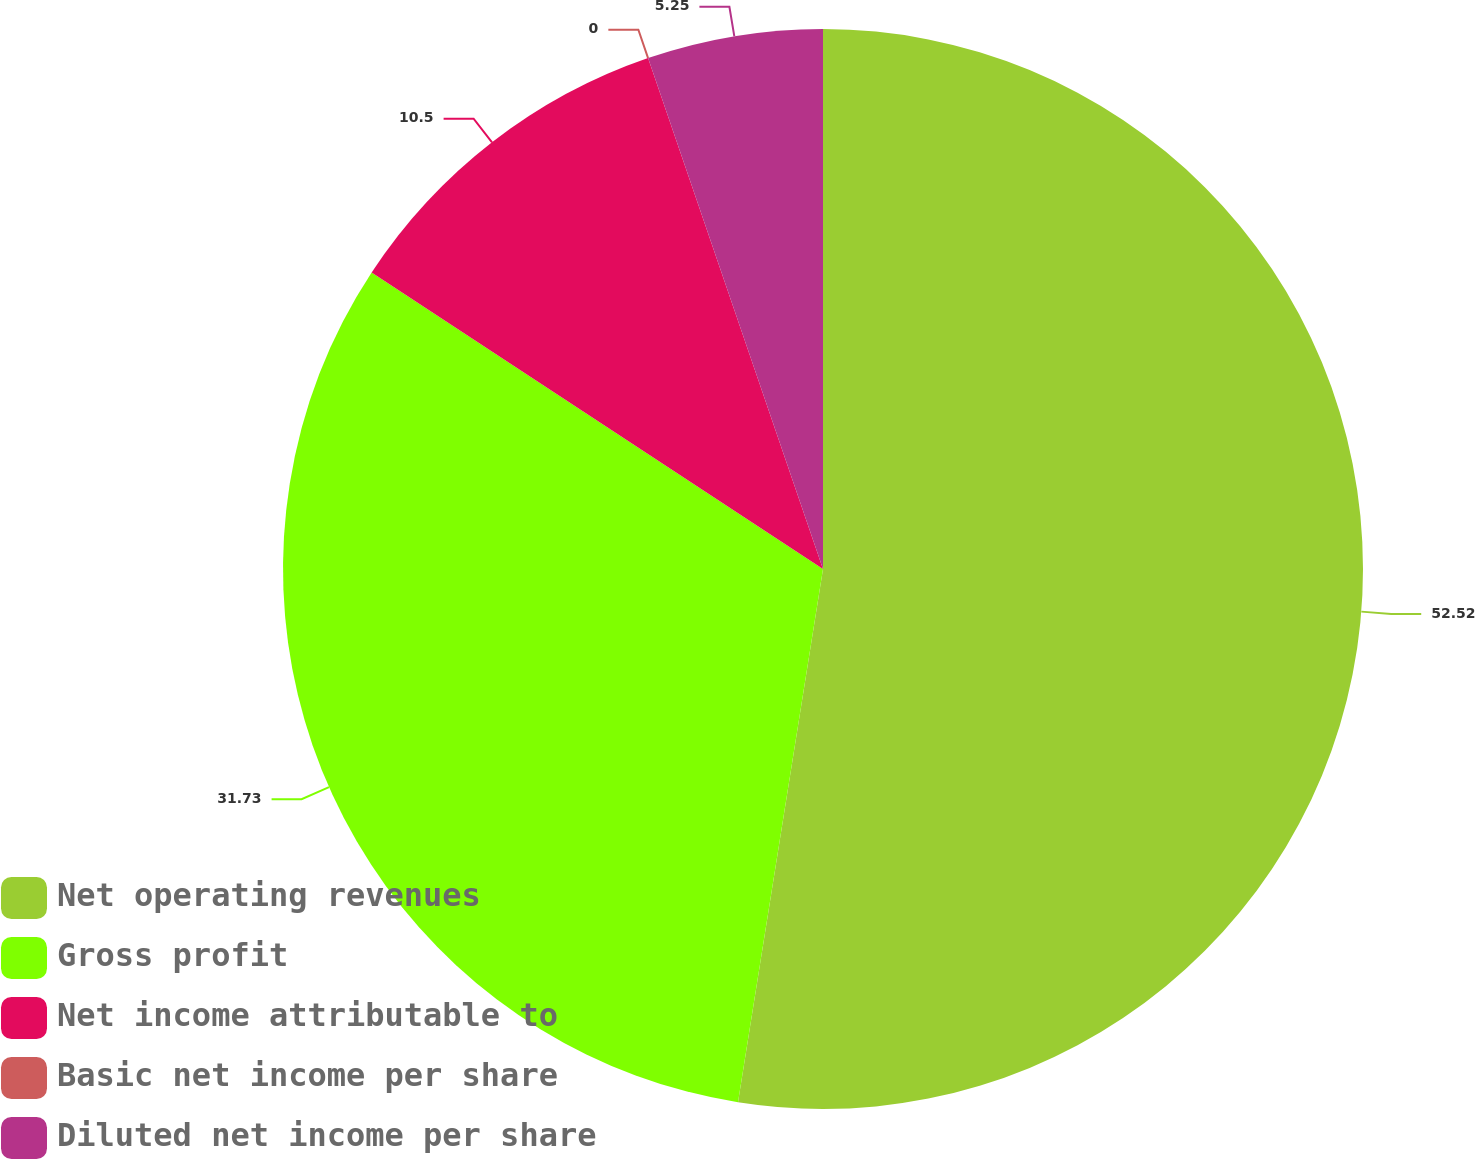Convert chart. <chart><loc_0><loc_0><loc_500><loc_500><pie_chart><fcel>Net operating revenues<fcel>Gross profit<fcel>Net income attributable to<fcel>Basic net income per share<fcel>Diluted net income per share<nl><fcel>52.51%<fcel>31.73%<fcel>10.5%<fcel>0.0%<fcel>5.25%<nl></chart> 